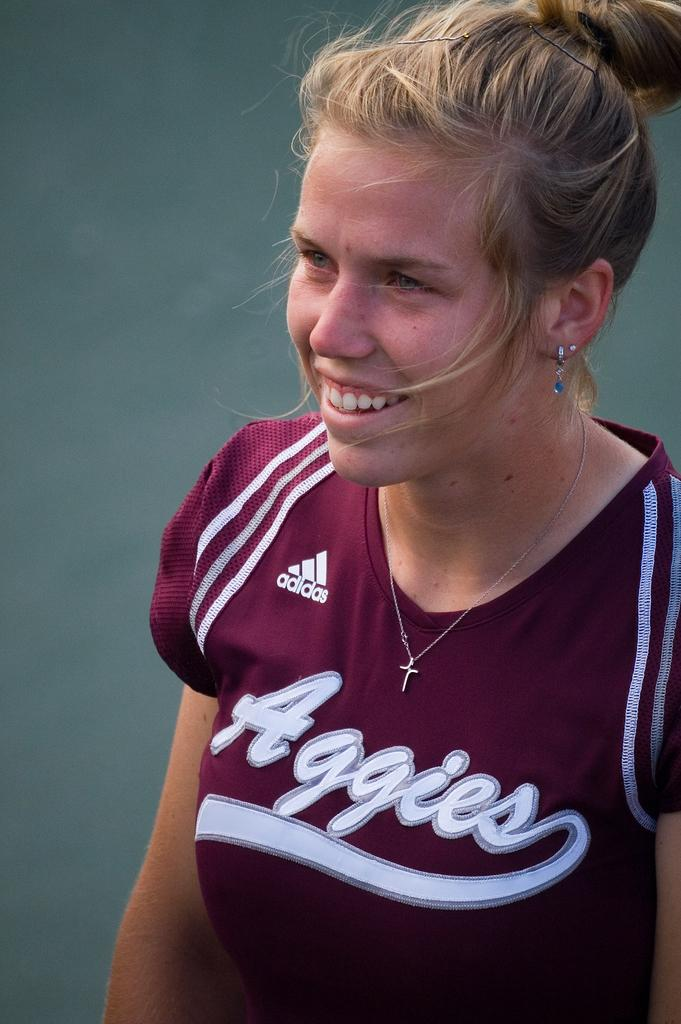<image>
Provide a brief description of the given image. A lady is smiling while wearing an adidas jersey. 